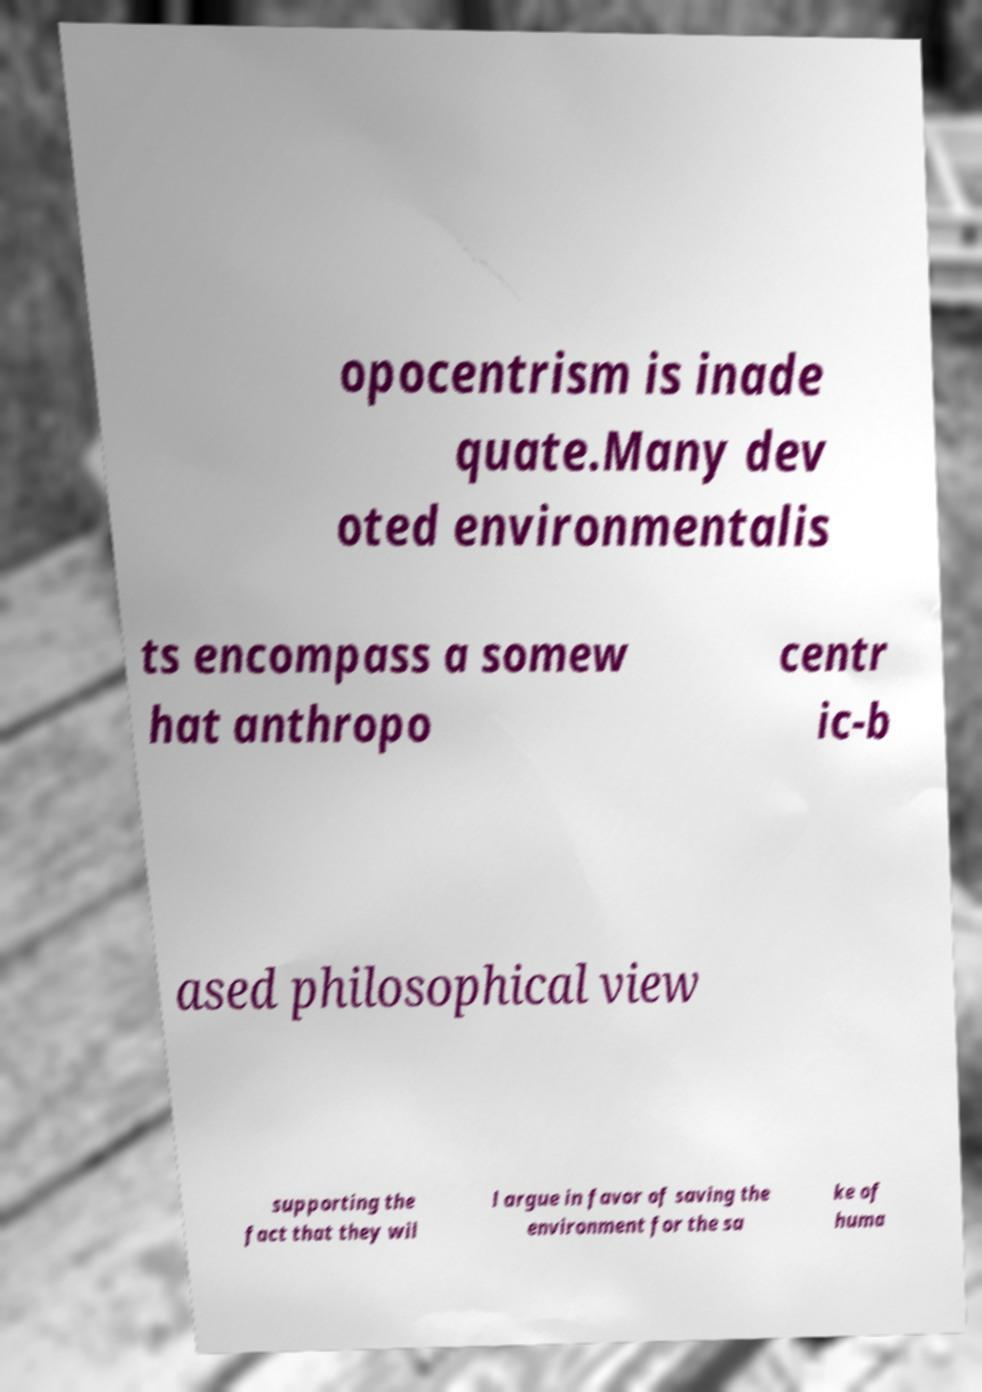Please read and relay the text visible in this image. What does it say? opocentrism is inade quate.Many dev oted environmentalis ts encompass a somew hat anthropo centr ic-b ased philosophical view supporting the fact that they wil l argue in favor of saving the environment for the sa ke of huma 